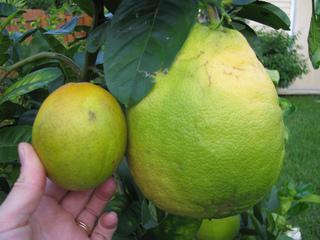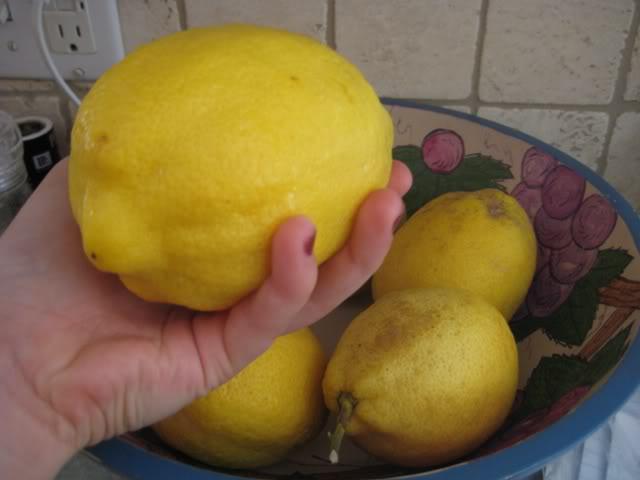The first image is the image on the left, the second image is the image on the right. Analyze the images presented: Is the assertion "The left image shows two fruit next to each other, one large and one small, while the right image shows at least three fruit in a bowl." valid? Answer yes or no. Yes. The first image is the image on the left, the second image is the image on the right. Analyze the images presented: Is the assertion "The right image includes yellow fruit in a round bowl, and the left image shows a small fruit on the left of a larger fruit of the same color." valid? Answer yes or no. Yes. 